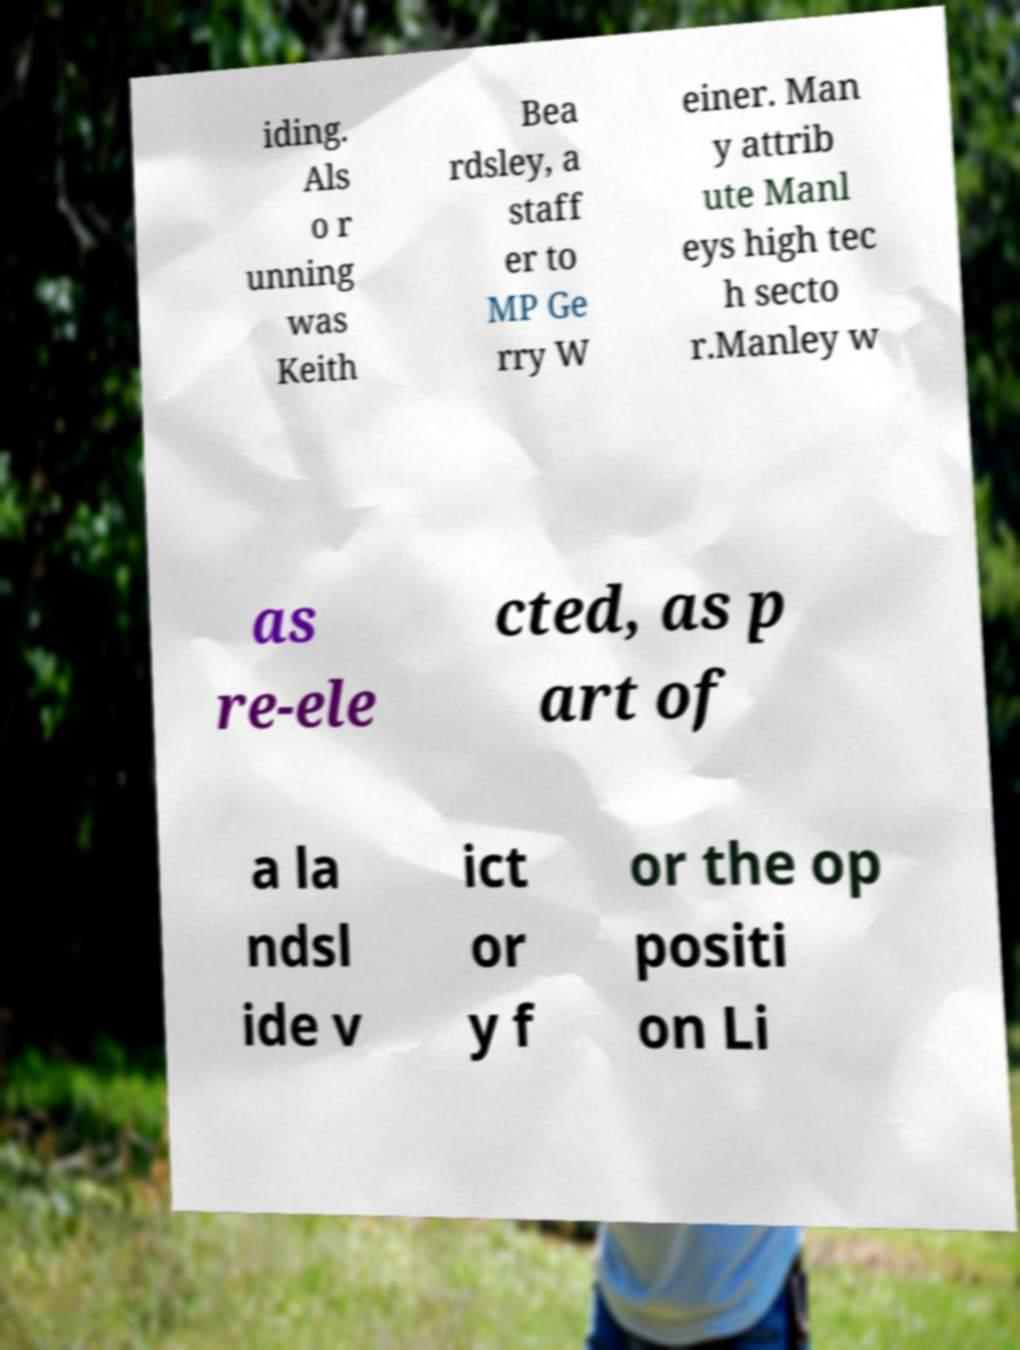There's text embedded in this image that I need extracted. Can you transcribe it verbatim? iding. Als o r unning was Keith Bea rdsley, a staff er to MP Ge rry W einer. Man y attrib ute Manl eys high tec h secto r.Manley w as re-ele cted, as p art of a la ndsl ide v ict or y f or the op positi on Li 